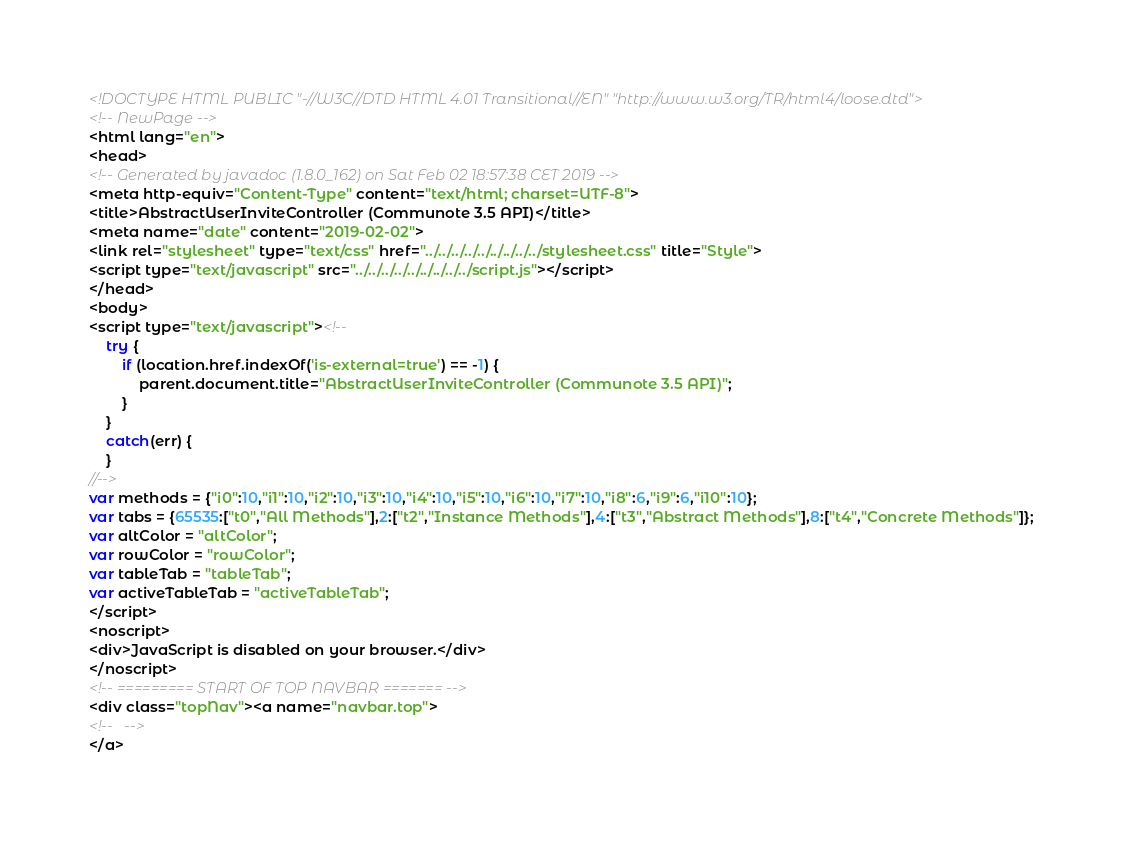Convert code to text. <code><loc_0><loc_0><loc_500><loc_500><_HTML_><!DOCTYPE HTML PUBLIC "-//W3C//DTD HTML 4.01 Transitional//EN" "http://www.w3.org/TR/html4/loose.dtd">
<!-- NewPage -->
<html lang="en">
<head>
<!-- Generated by javadoc (1.8.0_162) on Sat Feb 02 18:57:38 CET 2019 -->
<meta http-equiv="Content-Type" content="text/html; charset=UTF-8">
<title>AbstractUserInviteController (Communote 3.5 API)</title>
<meta name="date" content="2019-02-02">
<link rel="stylesheet" type="text/css" href="../../../../../../../../../stylesheet.css" title="Style">
<script type="text/javascript" src="../../../../../../../../../script.js"></script>
</head>
<body>
<script type="text/javascript"><!--
    try {
        if (location.href.indexOf('is-external=true') == -1) {
            parent.document.title="AbstractUserInviteController (Communote 3.5 API)";
        }
    }
    catch(err) {
    }
//-->
var methods = {"i0":10,"i1":10,"i2":10,"i3":10,"i4":10,"i5":10,"i6":10,"i7":10,"i8":6,"i9":6,"i10":10};
var tabs = {65535:["t0","All Methods"],2:["t2","Instance Methods"],4:["t3","Abstract Methods"],8:["t4","Concrete Methods"]};
var altColor = "altColor";
var rowColor = "rowColor";
var tableTab = "tableTab";
var activeTableTab = "activeTableTab";
</script>
<noscript>
<div>JavaScript is disabled on your browser.</div>
</noscript>
<!-- ========= START OF TOP NAVBAR ======= -->
<div class="topNav"><a name="navbar.top">
<!--   -->
</a></code> 